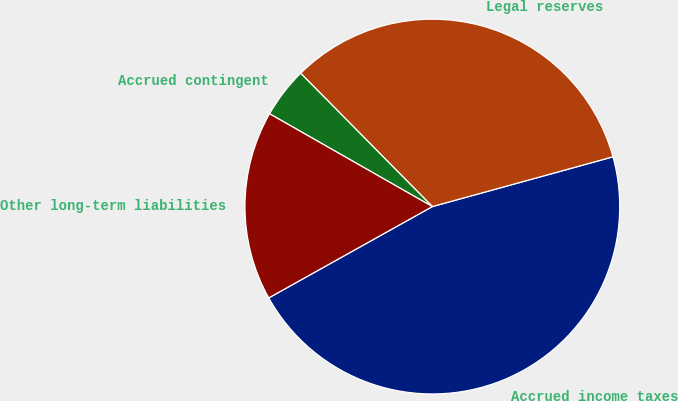Convert chart. <chart><loc_0><loc_0><loc_500><loc_500><pie_chart><fcel>Accrued income taxes<fcel>Legal reserves<fcel>Accrued contingent<fcel>Other long-term liabilities<nl><fcel>46.17%<fcel>33.12%<fcel>4.35%<fcel>16.35%<nl></chart> 